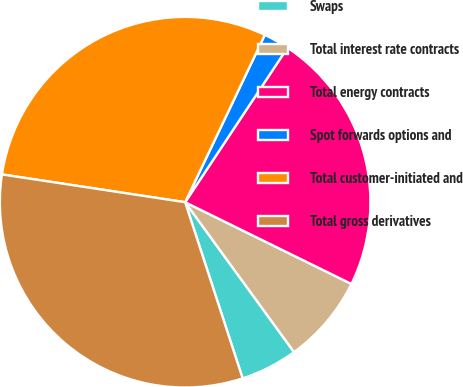Convert chart. <chart><loc_0><loc_0><loc_500><loc_500><pie_chart><fcel>Swaps<fcel>Total interest rate contracts<fcel>Total energy contracts<fcel>Spot forwards options and<fcel>Total customer-initiated and<fcel>Total gross derivatives<nl><fcel>4.98%<fcel>7.73%<fcel>22.96%<fcel>2.24%<fcel>29.68%<fcel>32.42%<nl></chart> 